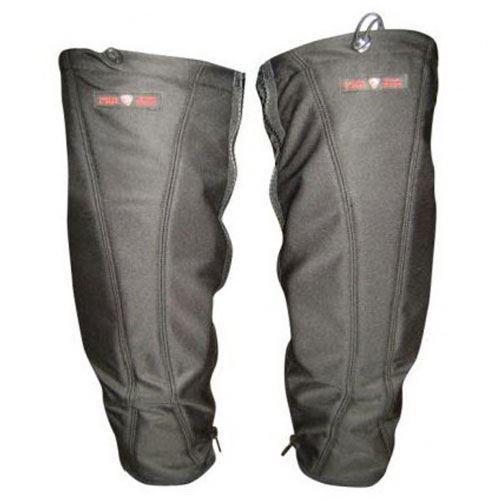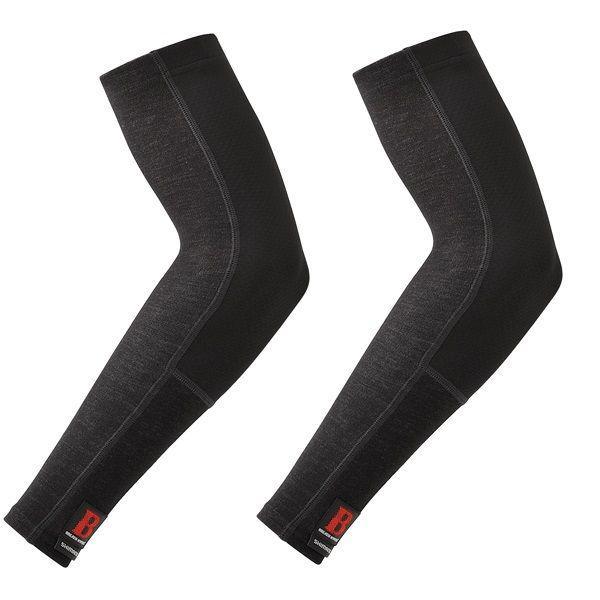The first image is the image on the left, the second image is the image on the right. Given the left and right images, does the statement "Each image includes at least one human leg with exposed skin, and each human leg wears a knee wrap." hold true? Answer yes or no. No. The first image is the image on the left, the second image is the image on the right. Evaluate the accuracy of this statement regarding the images: "The left and right image each have at least on all black knee pads minus the labeling.". Is it true? Answer yes or no. No. 